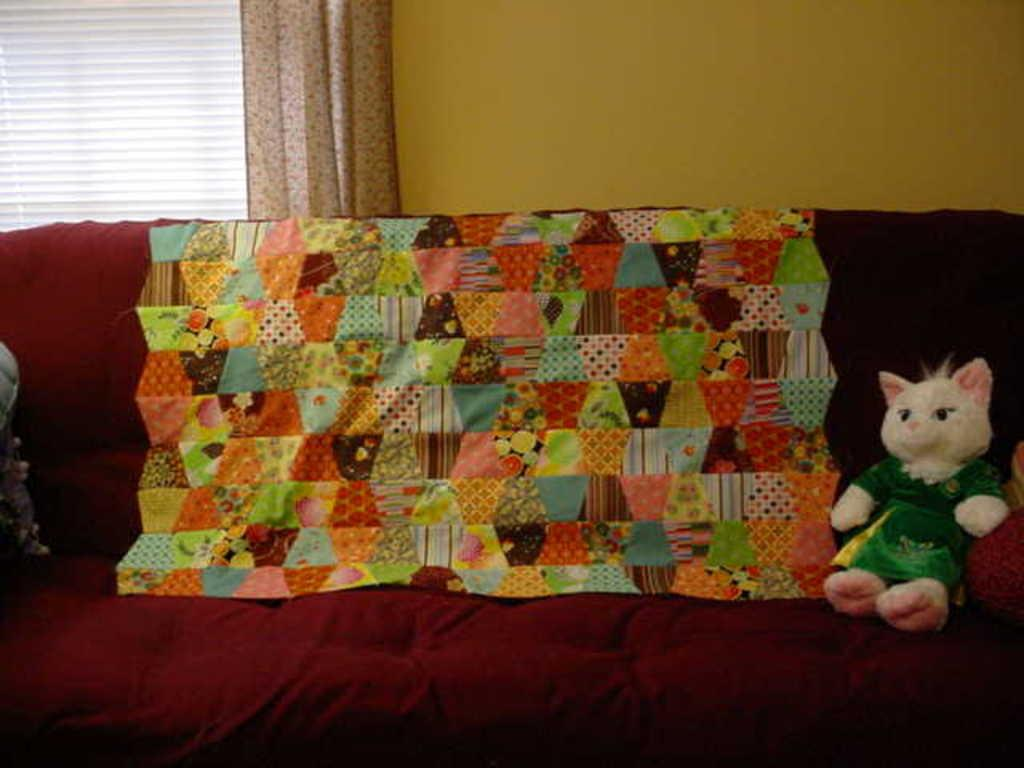What is the main subject in the image? There is a doll in the image. What else can be seen on the sofa in the image? There are objects on the sofa. What is visible in the background of the image? There is a wall, a curtain, and a window blind in the background of the image. What type of steel is used to construct the hospital in the image? There is no hospital or steel present in the image; it features a doll and various objects in a room. 